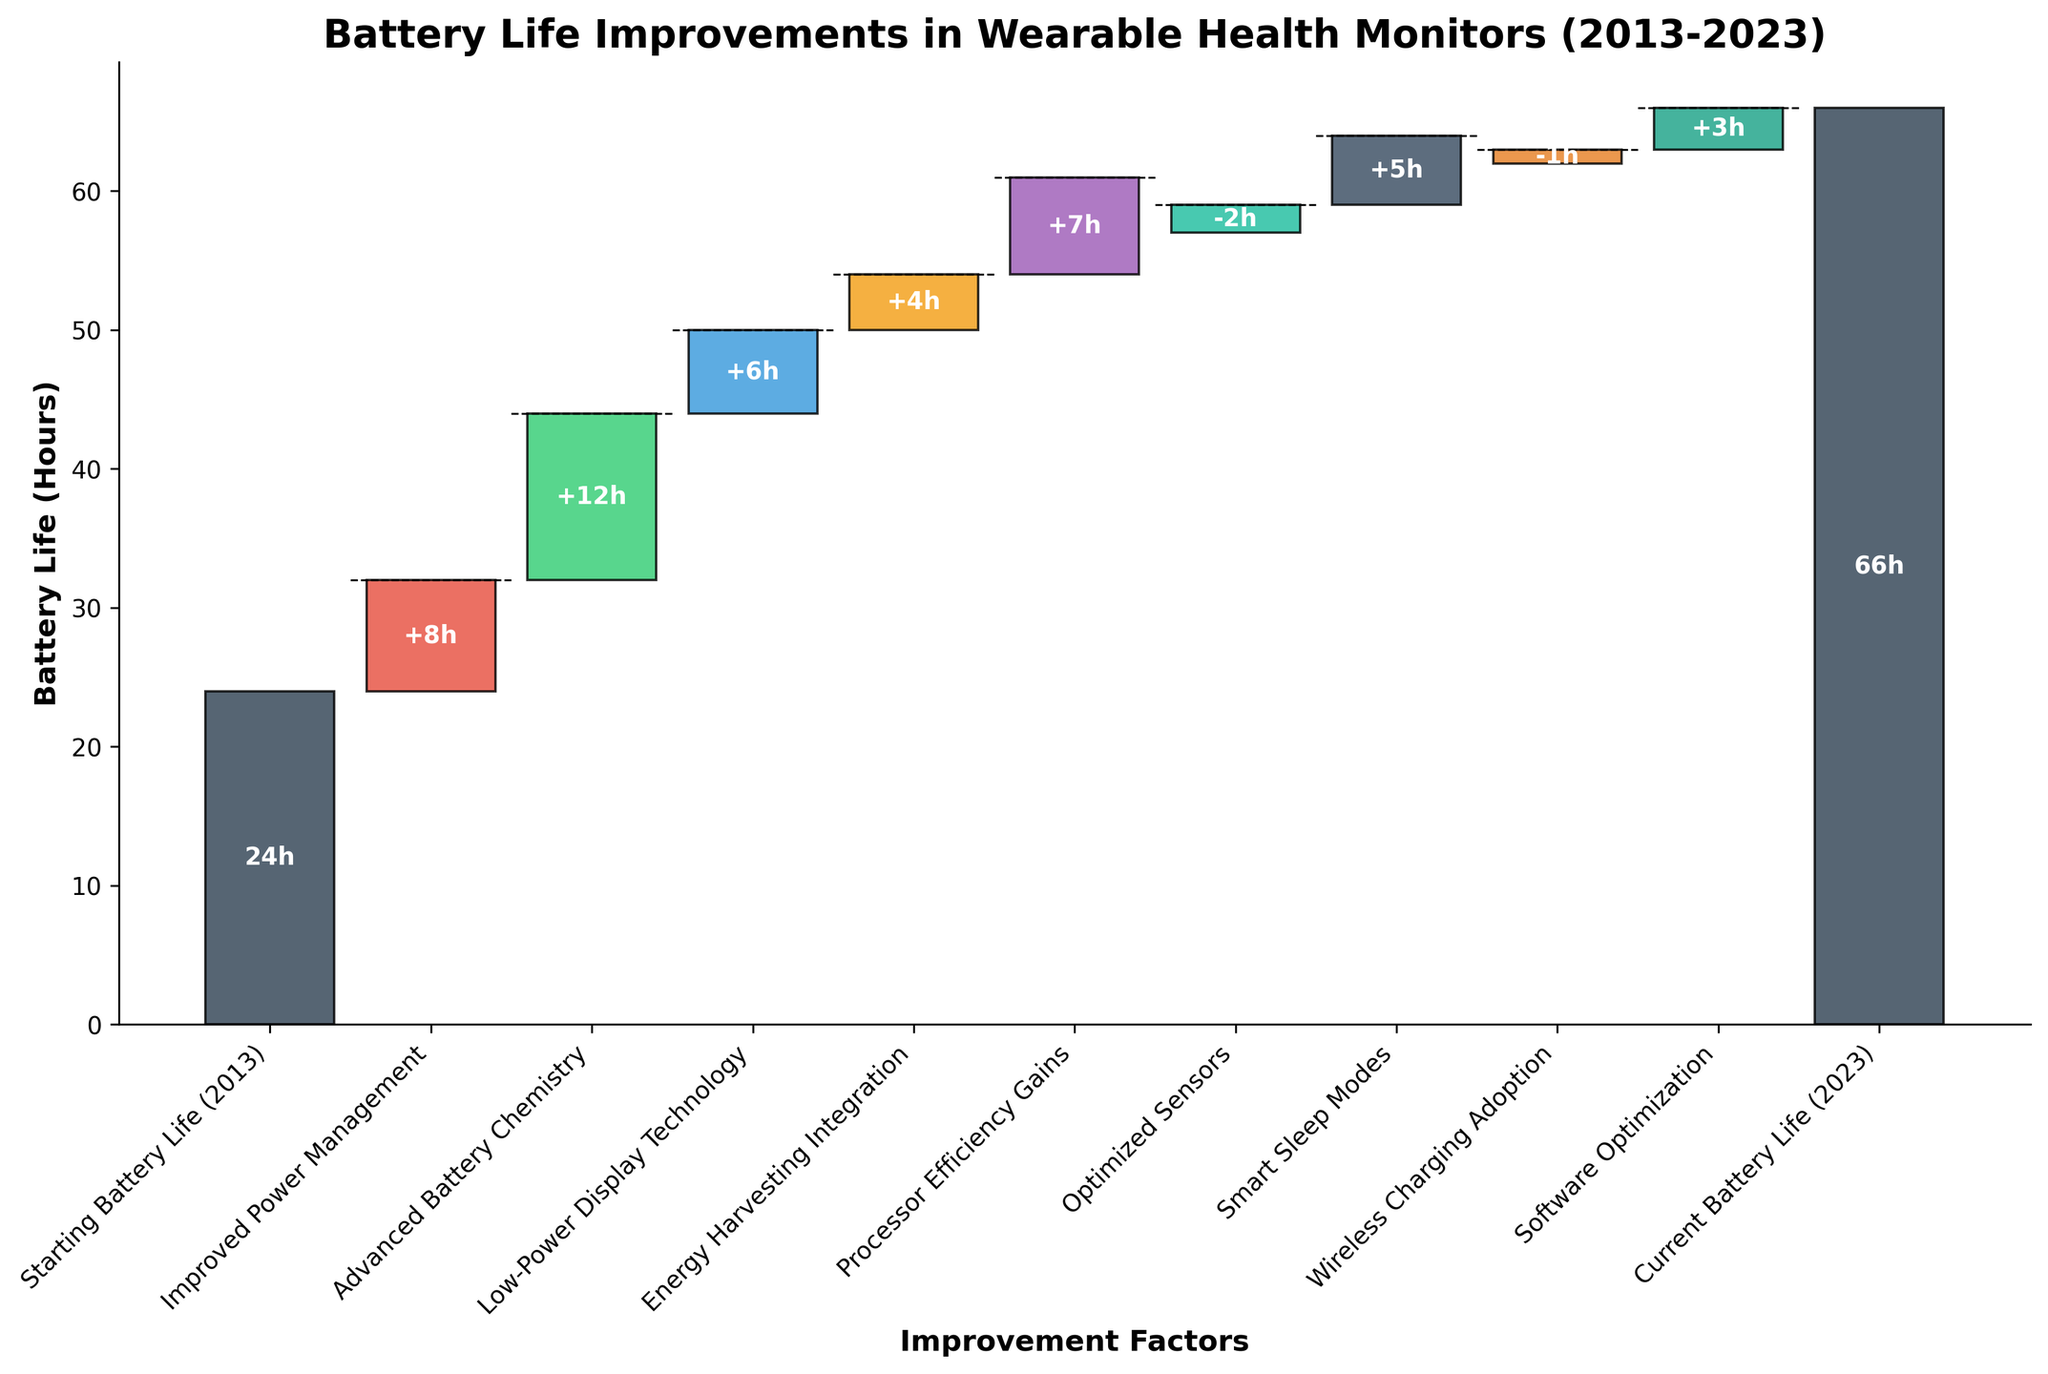What's the title of the chart? The title of the chart is displayed at the top and reads "Battery Life Improvements in Wearable Health Monitors (2013-2023)."
Answer: Battery Life Improvements in Wearable Health Monitors (2013-2023) How many improvement factors are listed in the chart? The x-axis lists the improvement factors. Counting them, we see there are 9 improvement factors displayed in the chart.
Answer: 9 Which improvement factor contributed the most to battery life increase? By comparing the heights of the bars representing each improvement factor, "Advanced Battery Chemistry" with 12 hours is the highest, indicating the most significant contribution.
Answer: Advanced Battery Chemistry Which category has a negative contribution to the battery life? The categories corresponding to negative values have bars extending downwards. "Optimized Sensors" (-2 hours) and "Wireless Charging Adoption" (-1 hour) are the categories with negative contributions.
Answer: Optimized Sensors, Wireless Charging Adoption What was the total contribution of all improvement factors combined? Adding all the improvement factors together: 8 + 12 + 6 + 4 + 7 - 2 + 5 - 1 + 3 = 42 hours.
Answer: 42 hours What is the current battery life in 2023? The cumulative bar at the end of the chart representing "Current Battery Life (2023)" shows the numerical value of 66 hours.
Answer: 66 hours How much did the "Improved Power Management" factor improve battery life by? The bar for "Improved Power Management" shows an increase and the value label indicates an improvement of 8 hours.
Answer: 8 hours What was the battery life in 2013 and how much did it improve by 2023? The initial bar titled "Starting Battery Life (2013)" indicates 24 hours, and the final value under "Current Battery Life (2023)" is 66 hours. The improvement is 66 - 24 = 42 hours.
Answer: 66 hours, 42 hours Which improvement factor had a lesser impact on battery life compared to "Processor Efficiency Gains"? Comparing the bars, "Smart Sleep Modes" (5 hours) and "Software Optimization" (3 hours) had lesser impacts than "Processor Efficiency Gains" (7 hours). Among these, "Software Optimization" had the least impact.
Answer: Software Optimization 